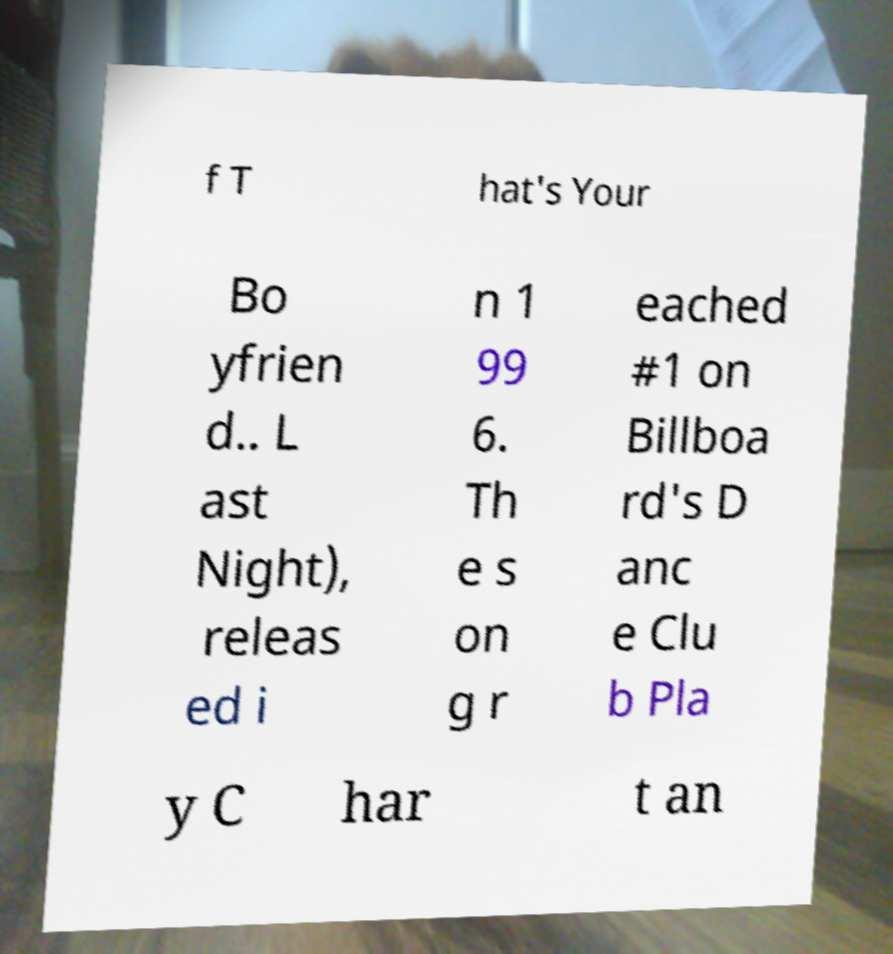Can you read and provide the text displayed in the image?This photo seems to have some interesting text. Can you extract and type it out for me? f T hat's Your Bo yfrien d.. L ast Night), releas ed i n 1 99 6. Th e s on g r eached #1 on Billboa rd's D anc e Clu b Pla y C har t an 